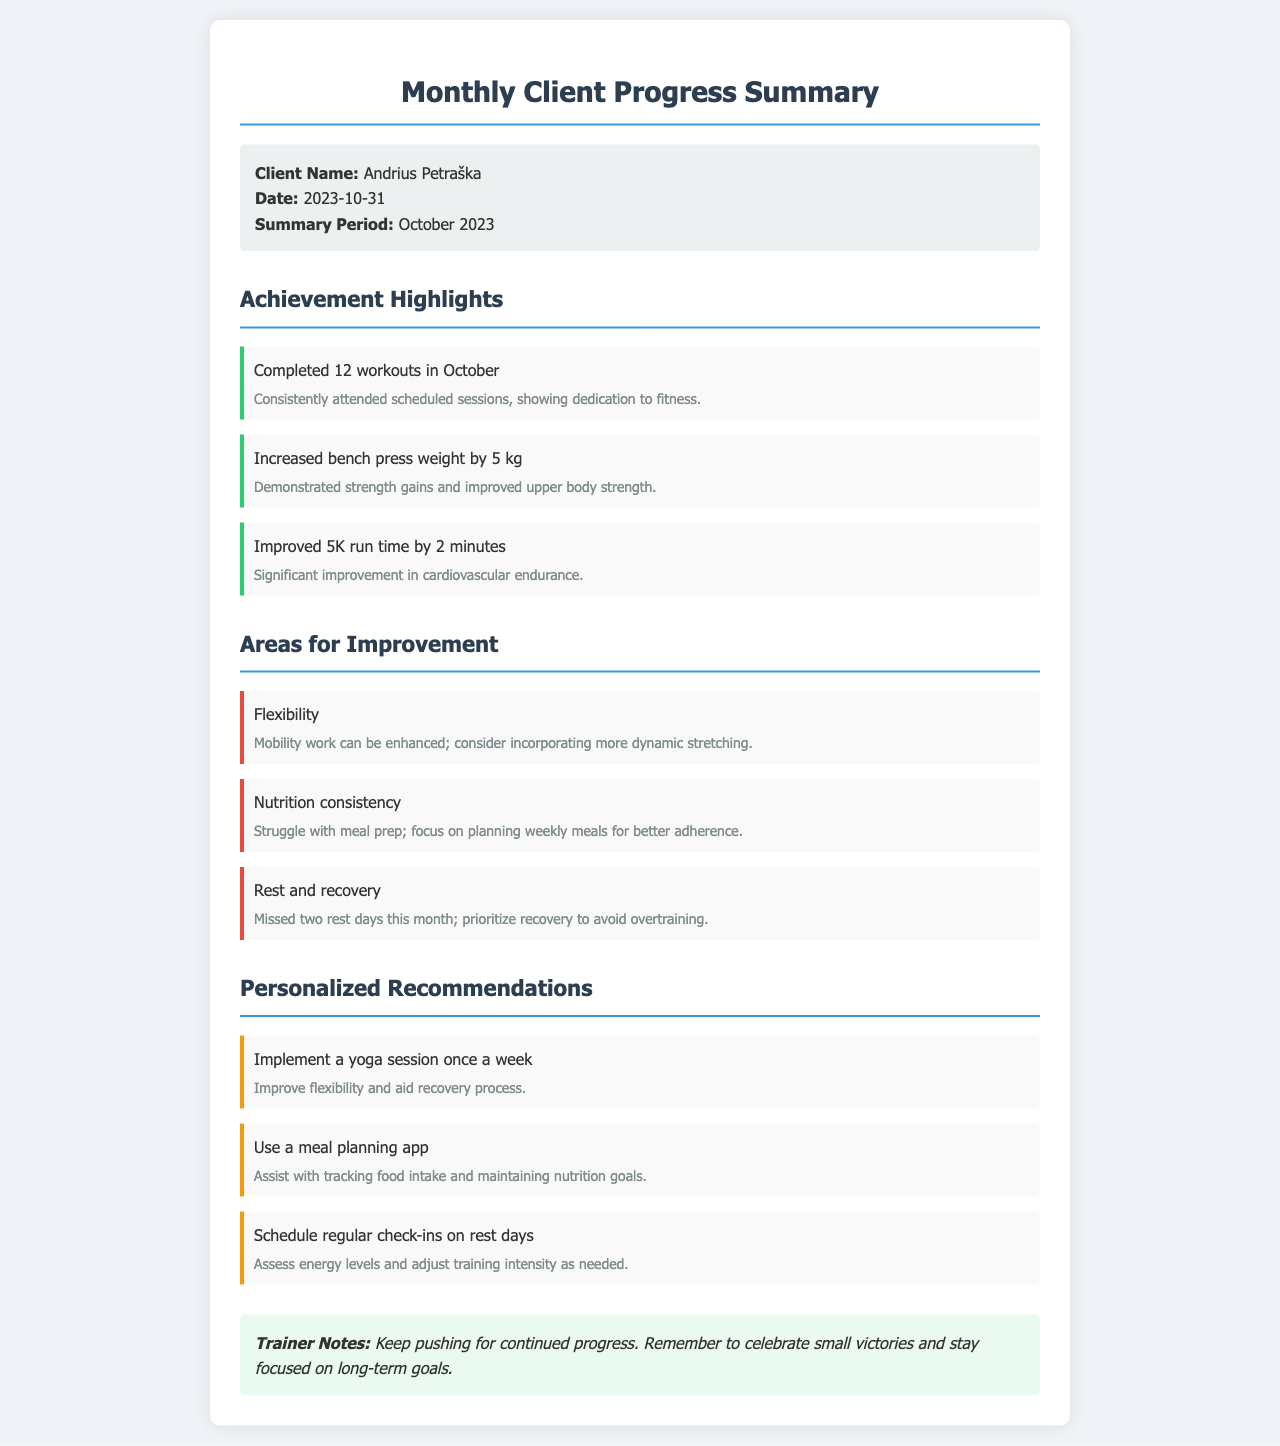what is the client's name? The client's name is explicitly listed in the document.
Answer: Andrius Petraška when was the summary created? The date is provided in the client info section of the document.
Answer: 2023-10-31 how many workouts did the client complete in October? The number of workouts is detailed in the achievement highlights section.
Answer: 12 what improvement was mentioned regarding nutrition? This information is found in the areas for improvement section and focuses on meal prep.
Answer: Nutrition consistency by how much did the client increase their bench press weight? The increase in weight is stated in the achievement highlights section.
Answer: 5 kg what is one recommendation for improving flexibility? This is found in the personalized recommendations section and pertains to yoga.
Answer: Implement a yoga session once a week how did the client's 5K run time change? This change is specified in the achievement highlights, reflecting improvement.
Answer: Improved by 2 minutes what area needs better planning according to the report? This is addressed in the areas for improvement and refers to meal prep.
Answer: Nutrition consistency what activities could improve recovery according to the recommendations? The recommendation section discusses various activities to aid recovery.
Answer: Regular check-ins on rest days 